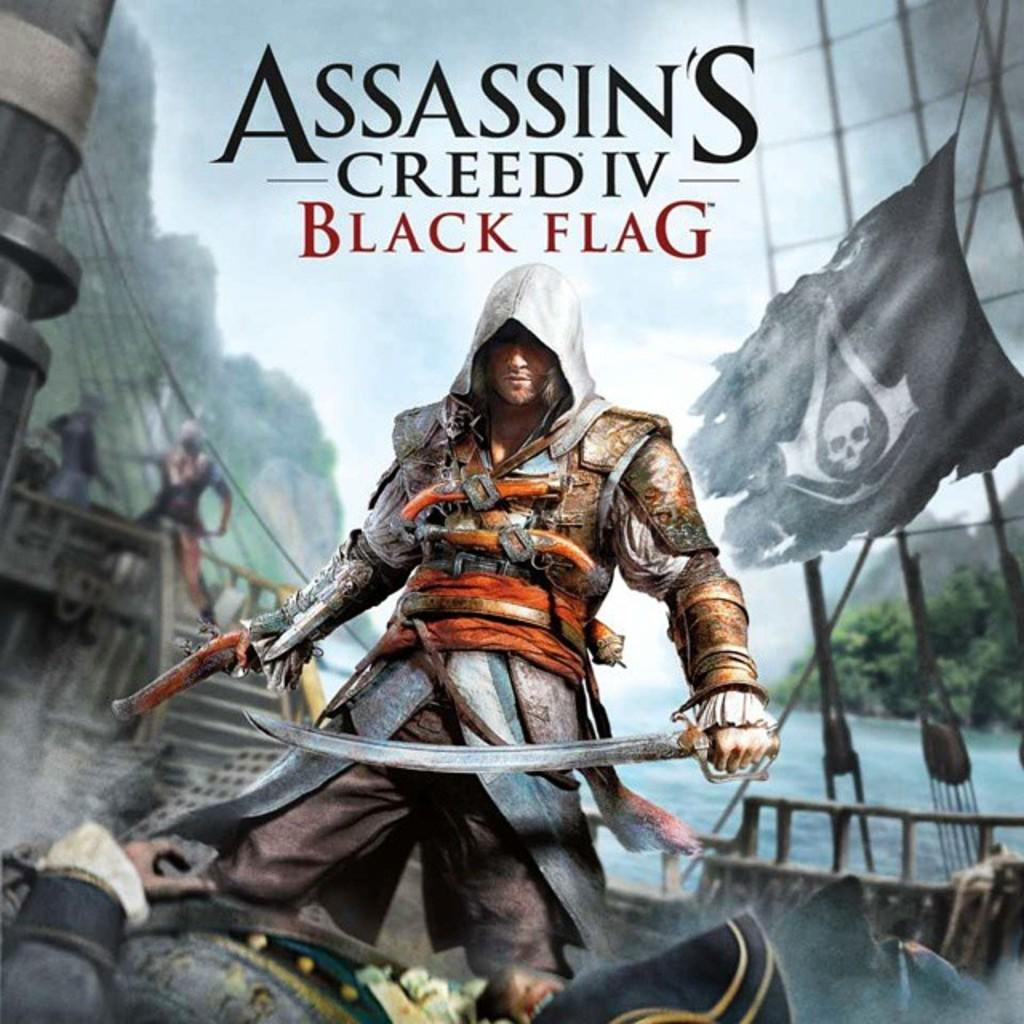<image>
Describe the image concisely. a cover of a video game for Assassin's Creed IV Black Flag 